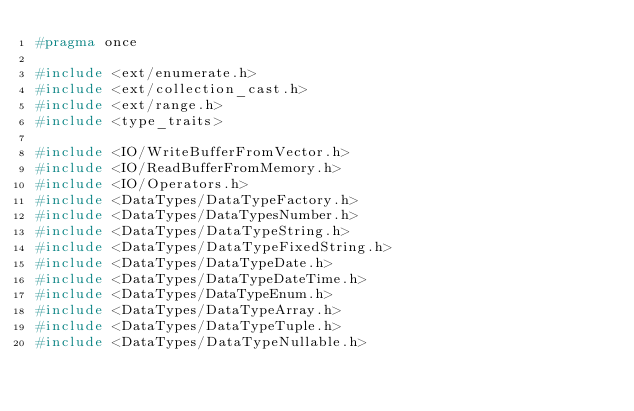Convert code to text. <code><loc_0><loc_0><loc_500><loc_500><_C_>#pragma once

#include <ext/enumerate.h>
#include <ext/collection_cast.h>
#include <ext/range.h>
#include <type_traits>

#include <IO/WriteBufferFromVector.h>
#include <IO/ReadBufferFromMemory.h>
#include <IO/Operators.h>
#include <DataTypes/DataTypeFactory.h>
#include <DataTypes/DataTypesNumber.h>
#include <DataTypes/DataTypeString.h>
#include <DataTypes/DataTypeFixedString.h>
#include <DataTypes/DataTypeDate.h>
#include <DataTypes/DataTypeDateTime.h>
#include <DataTypes/DataTypeEnum.h>
#include <DataTypes/DataTypeArray.h>
#include <DataTypes/DataTypeTuple.h>
#include <DataTypes/DataTypeNullable.h></code> 